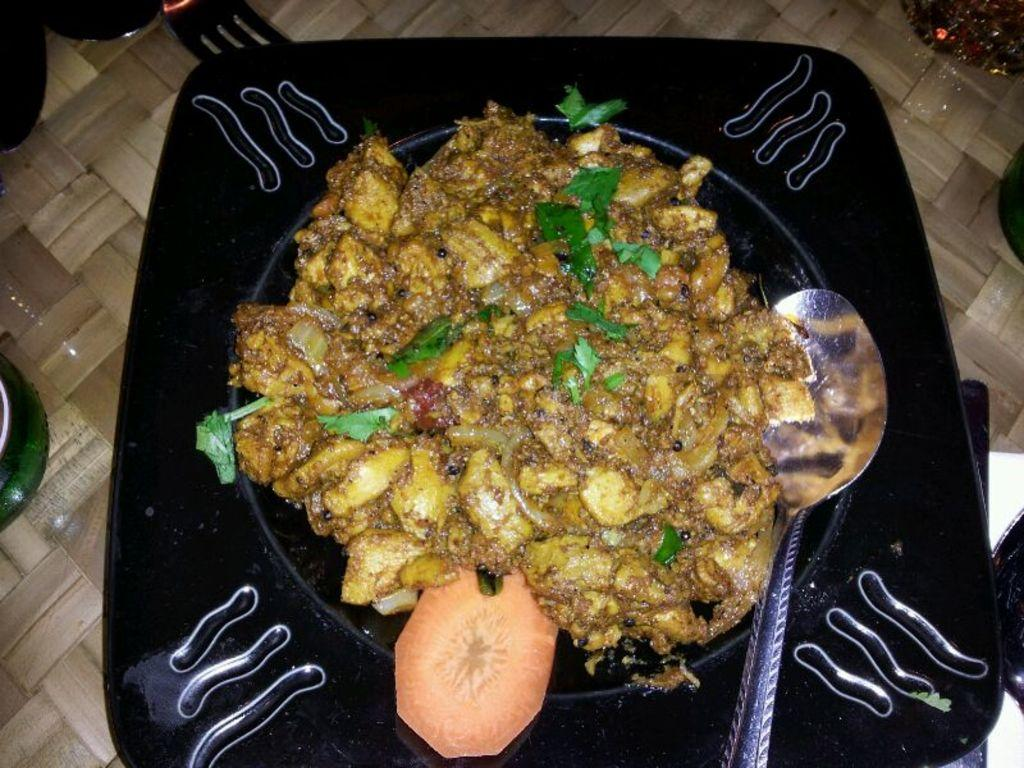What is the main object on the plate in the image? There is food served on a plate in the image. Can you identify any specific food item in the image? Yes, there is a carrot slice in the image. What utensil is present in the image? There is a spoon in the image. Where is the plate and its contents located? The plate and objects are on a table in the image. What other unspecified objects can be seen in the image? There are some other unspecified objects in the image, but their details are not mentioned in the provided facts. What type of bead is used to ask a question in the image? There is no bead or question present in the image; it features a plate with food, a carrot slice, a spoon, and other unspecified objects on a table. 